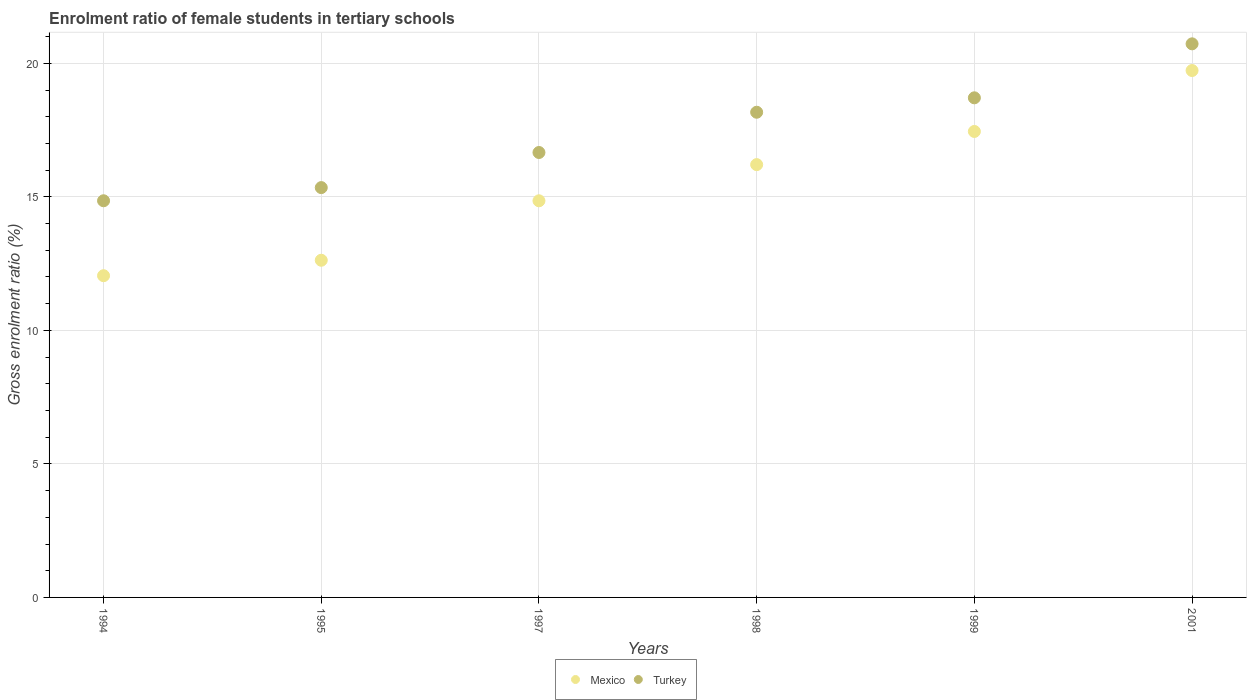How many different coloured dotlines are there?
Your response must be concise. 2. Is the number of dotlines equal to the number of legend labels?
Offer a very short reply. Yes. What is the enrolment ratio of female students in tertiary schools in Turkey in 1998?
Provide a short and direct response. 18.17. Across all years, what is the maximum enrolment ratio of female students in tertiary schools in Turkey?
Your answer should be very brief. 20.73. Across all years, what is the minimum enrolment ratio of female students in tertiary schools in Turkey?
Your answer should be very brief. 14.85. What is the total enrolment ratio of female students in tertiary schools in Turkey in the graph?
Provide a succinct answer. 104.46. What is the difference between the enrolment ratio of female students in tertiary schools in Turkey in 1995 and that in 1999?
Your answer should be very brief. -3.36. What is the difference between the enrolment ratio of female students in tertiary schools in Mexico in 1998 and the enrolment ratio of female students in tertiary schools in Turkey in 1994?
Offer a terse response. 1.35. What is the average enrolment ratio of female students in tertiary schools in Turkey per year?
Your response must be concise. 17.41. In the year 1999, what is the difference between the enrolment ratio of female students in tertiary schools in Mexico and enrolment ratio of female students in tertiary schools in Turkey?
Make the answer very short. -1.26. In how many years, is the enrolment ratio of female students in tertiary schools in Mexico greater than 8 %?
Keep it short and to the point. 6. What is the ratio of the enrolment ratio of female students in tertiary schools in Turkey in 1995 to that in 2001?
Provide a short and direct response. 0.74. Is the enrolment ratio of female students in tertiary schools in Turkey in 1994 less than that in 1995?
Keep it short and to the point. Yes. What is the difference between the highest and the second highest enrolment ratio of female students in tertiary schools in Turkey?
Keep it short and to the point. 2.02. What is the difference between the highest and the lowest enrolment ratio of female students in tertiary schools in Turkey?
Your answer should be compact. 5.88. In how many years, is the enrolment ratio of female students in tertiary schools in Mexico greater than the average enrolment ratio of female students in tertiary schools in Mexico taken over all years?
Offer a very short reply. 3. Is the sum of the enrolment ratio of female students in tertiary schools in Mexico in 1994 and 1998 greater than the maximum enrolment ratio of female students in tertiary schools in Turkey across all years?
Offer a terse response. Yes. Does the enrolment ratio of female students in tertiary schools in Turkey monotonically increase over the years?
Offer a terse response. Yes. Are the values on the major ticks of Y-axis written in scientific E-notation?
Your answer should be compact. No. What is the title of the graph?
Provide a short and direct response. Enrolment ratio of female students in tertiary schools. Does "Serbia" appear as one of the legend labels in the graph?
Offer a terse response. No. What is the label or title of the Y-axis?
Your answer should be very brief. Gross enrolment ratio (%). What is the Gross enrolment ratio (%) in Mexico in 1994?
Offer a terse response. 12.05. What is the Gross enrolment ratio (%) in Turkey in 1994?
Give a very brief answer. 14.85. What is the Gross enrolment ratio (%) of Mexico in 1995?
Offer a very short reply. 12.63. What is the Gross enrolment ratio (%) of Turkey in 1995?
Give a very brief answer. 15.35. What is the Gross enrolment ratio (%) in Mexico in 1997?
Give a very brief answer. 14.85. What is the Gross enrolment ratio (%) of Turkey in 1997?
Offer a terse response. 16.66. What is the Gross enrolment ratio (%) in Mexico in 1998?
Your response must be concise. 16.21. What is the Gross enrolment ratio (%) in Turkey in 1998?
Keep it short and to the point. 18.17. What is the Gross enrolment ratio (%) in Mexico in 1999?
Your answer should be compact. 17.45. What is the Gross enrolment ratio (%) in Turkey in 1999?
Offer a very short reply. 18.71. What is the Gross enrolment ratio (%) of Mexico in 2001?
Provide a succinct answer. 19.73. What is the Gross enrolment ratio (%) in Turkey in 2001?
Offer a terse response. 20.73. Across all years, what is the maximum Gross enrolment ratio (%) in Mexico?
Give a very brief answer. 19.73. Across all years, what is the maximum Gross enrolment ratio (%) in Turkey?
Your answer should be very brief. 20.73. Across all years, what is the minimum Gross enrolment ratio (%) of Mexico?
Provide a short and direct response. 12.05. Across all years, what is the minimum Gross enrolment ratio (%) in Turkey?
Ensure brevity in your answer.  14.85. What is the total Gross enrolment ratio (%) in Mexico in the graph?
Provide a short and direct response. 92.91. What is the total Gross enrolment ratio (%) in Turkey in the graph?
Offer a terse response. 104.46. What is the difference between the Gross enrolment ratio (%) of Mexico in 1994 and that in 1995?
Make the answer very short. -0.58. What is the difference between the Gross enrolment ratio (%) in Turkey in 1994 and that in 1995?
Keep it short and to the point. -0.49. What is the difference between the Gross enrolment ratio (%) in Mexico in 1994 and that in 1997?
Offer a very short reply. -2.81. What is the difference between the Gross enrolment ratio (%) in Turkey in 1994 and that in 1997?
Offer a very short reply. -1.81. What is the difference between the Gross enrolment ratio (%) of Mexico in 1994 and that in 1998?
Your answer should be very brief. -4.16. What is the difference between the Gross enrolment ratio (%) of Turkey in 1994 and that in 1998?
Keep it short and to the point. -3.31. What is the difference between the Gross enrolment ratio (%) of Mexico in 1994 and that in 1999?
Your answer should be compact. -5.4. What is the difference between the Gross enrolment ratio (%) of Turkey in 1994 and that in 1999?
Keep it short and to the point. -3.85. What is the difference between the Gross enrolment ratio (%) in Mexico in 1994 and that in 2001?
Offer a very short reply. -7.68. What is the difference between the Gross enrolment ratio (%) in Turkey in 1994 and that in 2001?
Give a very brief answer. -5.88. What is the difference between the Gross enrolment ratio (%) in Mexico in 1995 and that in 1997?
Offer a very short reply. -2.23. What is the difference between the Gross enrolment ratio (%) of Turkey in 1995 and that in 1997?
Provide a succinct answer. -1.31. What is the difference between the Gross enrolment ratio (%) in Mexico in 1995 and that in 1998?
Your response must be concise. -3.58. What is the difference between the Gross enrolment ratio (%) in Turkey in 1995 and that in 1998?
Your response must be concise. -2.82. What is the difference between the Gross enrolment ratio (%) in Mexico in 1995 and that in 1999?
Offer a terse response. -4.82. What is the difference between the Gross enrolment ratio (%) of Turkey in 1995 and that in 1999?
Ensure brevity in your answer.  -3.36. What is the difference between the Gross enrolment ratio (%) in Mexico in 1995 and that in 2001?
Your answer should be very brief. -7.1. What is the difference between the Gross enrolment ratio (%) in Turkey in 1995 and that in 2001?
Make the answer very short. -5.38. What is the difference between the Gross enrolment ratio (%) in Mexico in 1997 and that in 1998?
Offer a terse response. -1.35. What is the difference between the Gross enrolment ratio (%) in Turkey in 1997 and that in 1998?
Make the answer very short. -1.51. What is the difference between the Gross enrolment ratio (%) of Mexico in 1997 and that in 1999?
Make the answer very short. -2.6. What is the difference between the Gross enrolment ratio (%) in Turkey in 1997 and that in 1999?
Offer a terse response. -2.05. What is the difference between the Gross enrolment ratio (%) of Mexico in 1997 and that in 2001?
Offer a terse response. -4.88. What is the difference between the Gross enrolment ratio (%) in Turkey in 1997 and that in 2001?
Offer a very short reply. -4.07. What is the difference between the Gross enrolment ratio (%) in Mexico in 1998 and that in 1999?
Keep it short and to the point. -1.24. What is the difference between the Gross enrolment ratio (%) in Turkey in 1998 and that in 1999?
Offer a terse response. -0.54. What is the difference between the Gross enrolment ratio (%) in Mexico in 1998 and that in 2001?
Make the answer very short. -3.52. What is the difference between the Gross enrolment ratio (%) of Turkey in 1998 and that in 2001?
Offer a very short reply. -2.56. What is the difference between the Gross enrolment ratio (%) in Mexico in 1999 and that in 2001?
Keep it short and to the point. -2.28. What is the difference between the Gross enrolment ratio (%) in Turkey in 1999 and that in 2001?
Make the answer very short. -2.02. What is the difference between the Gross enrolment ratio (%) in Mexico in 1994 and the Gross enrolment ratio (%) in Turkey in 1995?
Provide a short and direct response. -3.3. What is the difference between the Gross enrolment ratio (%) in Mexico in 1994 and the Gross enrolment ratio (%) in Turkey in 1997?
Give a very brief answer. -4.61. What is the difference between the Gross enrolment ratio (%) of Mexico in 1994 and the Gross enrolment ratio (%) of Turkey in 1998?
Your answer should be very brief. -6.12. What is the difference between the Gross enrolment ratio (%) of Mexico in 1994 and the Gross enrolment ratio (%) of Turkey in 1999?
Provide a short and direct response. -6.66. What is the difference between the Gross enrolment ratio (%) of Mexico in 1994 and the Gross enrolment ratio (%) of Turkey in 2001?
Keep it short and to the point. -8.68. What is the difference between the Gross enrolment ratio (%) of Mexico in 1995 and the Gross enrolment ratio (%) of Turkey in 1997?
Provide a short and direct response. -4.03. What is the difference between the Gross enrolment ratio (%) of Mexico in 1995 and the Gross enrolment ratio (%) of Turkey in 1998?
Your answer should be compact. -5.54. What is the difference between the Gross enrolment ratio (%) in Mexico in 1995 and the Gross enrolment ratio (%) in Turkey in 1999?
Provide a succinct answer. -6.08. What is the difference between the Gross enrolment ratio (%) of Mexico in 1995 and the Gross enrolment ratio (%) of Turkey in 2001?
Provide a succinct answer. -8.1. What is the difference between the Gross enrolment ratio (%) in Mexico in 1997 and the Gross enrolment ratio (%) in Turkey in 1998?
Keep it short and to the point. -3.32. What is the difference between the Gross enrolment ratio (%) in Mexico in 1997 and the Gross enrolment ratio (%) in Turkey in 1999?
Make the answer very short. -3.86. What is the difference between the Gross enrolment ratio (%) in Mexico in 1997 and the Gross enrolment ratio (%) in Turkey in 2001?
Give a very brief answer. -5.88. What is the difference between the Gross enrolment ratio (%) of Mexico in 1998 and the Gross enrolment ratio (%) of Turkey in 1999?
Give a very brief answer. -2.5. What is the difference between the Gross enrolment ratio (%) in Mexico in 1998 and the Gross enrolment ratio (%) in Turkey in 2001?
Keep it short and to the point. -4.52. What is the difference between the Gross enrolment ratio (%) in Mexico in 1999 and the Gross enrolment ratio (%) in Turkey in 2001?
Offer a terse response. -3.28. What is the average Gross enrolment ratio (%) of Mexico per year?
Ensure brevity in your answer.  15.48. What is the average Gross enrolment ratio (%) of Turkey per year?
Provide a short and direct response. 17.41. In the year 1994, what is the difference between the Gross enrolment ratio (%) in Mexico and Gross enrolment ratio (%) in Turkey?
Your response must be concise. -2.81. In the year 1995, what is the difference between the Gross enrolment ratio (%) in Mexico and Gross enrolment ratio (%) in Turkey?
Give a very brief answer. -2.72. In the year 1997, what is the difference between the Gross enrolment ratio (%) in Mexico and Gross enrolment ratio (%) in Turkey?
Offer a very short reply. -1.81. In the year 1998, what is the difference between the Gross enrolment ratio (%) of Mexico and Gross enrolment ratio (%) of Turkey?
Your response must be concise. -1.96. In the year 1999, what is the difference between the Gross enrolment ratio (%) of Mexico and Gross enrolment ratio (%) of Turkey?
Ensure brevity in your answer.  -1.26. In the year 2001, what is the difference between the Gross enrolment ratio (%) of Mexico and Gross enrolment ratio (%) of Turkey?
Ensure brevity in your answer.  -1. What is the ratio of the Gross enrolment ratio (%) of Mexico in 1994 to that in 1995?
Provide a short and direct response. 0.95. What is the ratio of the Gross enrolment ratio (%) of Turkey in 1994 to that in 1995?
Make the answer very short. 0.97. What is the ratio of the Gross enrolment ratio (%) of Mexico in 1994 to that in 1997?
Provide a short and direct response. 0.81. What is the ratio of the Gross enrolment ratio (%) in Turkey in 1994 to that in 1997?
Offer a terse response. 0.89. What is the ratio of the Gross enrolment ratio (%) in Mexico in 1994 to that in 1998?
Ensure brevity in your answer.  0.74. What is the ratio of the Gross enrolment ratio (%) in Turkey in 1994 to that in 1998?
Make the answer very short. 0.82. What is the ratio of the Gross enrolment ratio (%) of Mexico in 1994 to that in 1999?
Make the answer very short. 0.69. What is the ratio of the Gross enrolment ratio (%) of Turkey in 1994 to that in 1999?
Provide a short and direct response. 0.79. What is the ratio of the Gross enrolment ratio (%) of Mexico in 1994 to that in 2001?
Your response must be concise. 0.61. What is the ratio of the Gross enrolment ratio (%) of Turkey in 1994 to that in 2001?
Your response must be concise. 0.72. What is the ratio of the Gross enrolment ratio (%) in Mexico in 1995 to that in 1997?
Your response must be concise. 0.85. What is the ratio of the Gross enrolment ratio (%) of Turkey in 1995 to that in 1997?
Offer a very short reply. 0.92. What is the ratio of the Gross enrolment ratio (%) in Mexico in 1995 to that in 1998?
Offer a very short reply. 0.78. What is the ratio of the Gross enrolment ratio (%) of Turkey in 1995 to that in 1998?
Keep it short and to the point. 0.84. What is the ratio of the Gross enrolment ratio (%) of Mexico in 1995 to that in 1999?
Offer a terse response. 0.72. What is the ratio of the Gross enrolment ratio (%) of Turkey in 1995 to that in 1999?
Keep it short and to the point. 0.82. What is the ratio of the Gross enrolment ratio (%) of Mexico in 1995 to that in 2001?
Your answer should be very brief. 0.64. What is the ratio of the Gross enrolment ratio (%) of Turkey in 1995 to that in 2001?
Provide a succinct answer. 0.74. What is the ratio of the Gross enrolment ratio (%) of Mexico in 1997 to that in 1998?
Provide a succinct answer. 0.92. What is the ratio of the Gross enrolment ratio (%) in Turkey in 1997 to that in 1998?
Provide a succinct answer. 0.92. What is the ratio of the Gross enrolment ratio (%) in Mexico in 1997 to that in 1999?
Offer a very short reply. 0.85. What is the ratio of the Gross enrolment ratio (%) of Turkey in 1997 to that in 1999?
Ensure brevity in your answer.  0.89. What is the ratio of the Gross enrolment ratio (%) in Mexico in 1997 to that in 2001?
Your response must be concise. 0.75. What is the ratio of the Gross enrolment ratio (%) in Turkey in 1997 to that in 2001?
Your answer should be very brief. 0.8. What is the ratio of the Gross enrolment ratio (%) of Mexico in 1998 to that in 1999?
Give a very brief answer. 0.93. What is the ratio of the Gross enrolment ratio (%) of Turkey in 1998 to that in 1999?
Offer a terse response. 0.97. What is the ratio of the Gross enrolment ratio (%) of Mexico in 1998 to that in 2001?
Offer a very short reply. 0.82. What is the ratio of the Gross enrolment ratio (%) of Turkey in 1998 to that in 2001?
Offer a very short reply. 0.88. What is the ratio of the Gross enrolment ratio (%) in Mexico in 1999 to that in 2001?
Offer a terse response. 0.88. What is the ratio of the Gross enrolment ratio (%) of Turkey in 1999 to that in 2001?
Your answer should be very brief. 0.9. What is the difference between the highest and the second highest Gross enrolment ratio (%) in Mexico?
Keep it short and to the point. 2.28. What is the difference between the highest and the second highest Gross enrolment ratio (%) in Turkey?
Offer a terse response. 2.02. What is the difference between the highest and the lowest Gross enrolment ratio (%) of Mexico?
Keep it short and to the point. 7.68. What is the difference between the highest and the lowest Gross enrolment ratio (%) of Turkey?
Ensure brevity in your answer.  5.88. 